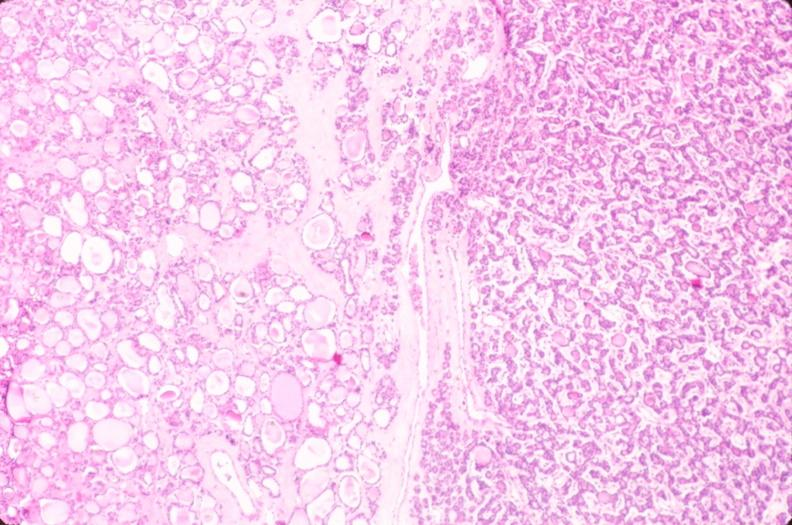does this image show thyroid, nodular hyperplasia?
Answer the question using a single word or phrase. Yes 